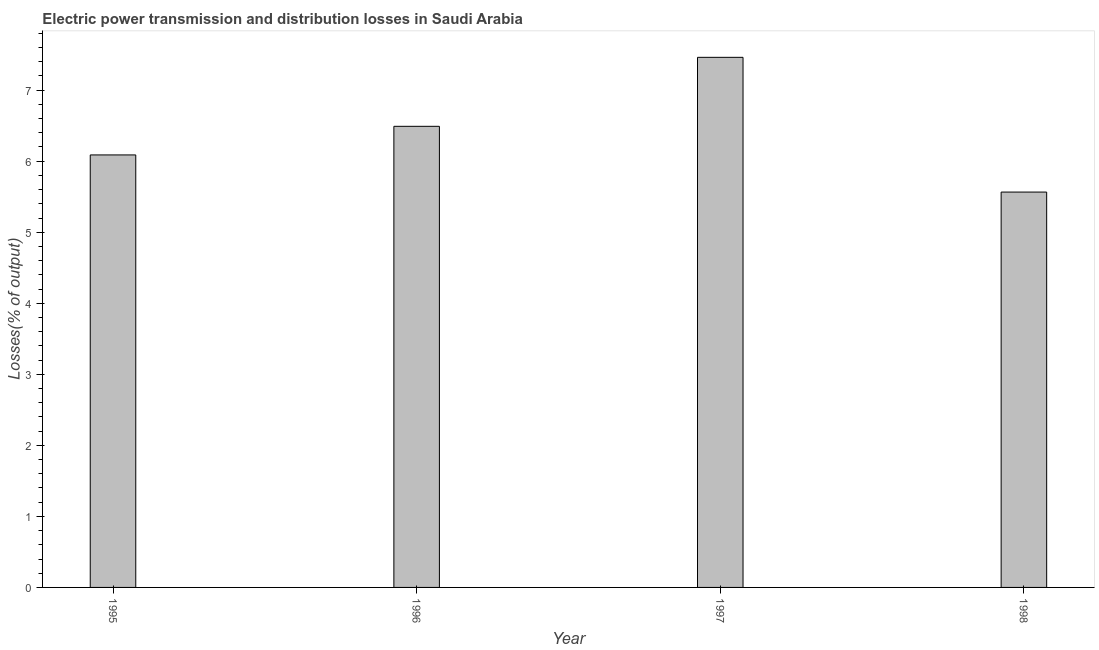Does the graph contain any zero values?
Offer a very short reply. No. Does the graph contain grids?
Keep it short and to the point. No. What is the title of the graph?
Provide a succinct answer. Electric power transmission and distribution losses in Saudi Arabia. What is the label or title of the Y-axis?
Your response must be concise. Losses(% of output). What is the electric power transmission and distribution losses in 1996?
Provide a succinct answer. 6.49. Across all years, what is the maximum electric power transmission and distribution losses?
Make the answer very short. 7.46. Across all years, what is the minimum electric power transmission and distribution losses?
Keep it short and to the point. 5.57. In which year was the electric power transmission and distribution losses maximum?
Your answer should be compact. 1997. What is the sum of the electric power transmission and distribution losses?
Keep it short and to the point. 25.61. What is the difference between the electric power transmission and distribution losses in 1995 and 1997?
Ensure brevity in your answer.  -1.37. What is the average electric power transmission and distribution losses per year?
Ensure brevity in your answer.  6.4. What is the median electric power transmission and distribution losses?
Your answer should be very brief. 6.29. What is the ratio of the electric power transmission and distribution losses in 1997 to that in 1998?
Provide a succinct answer. 1.34. Is the difference between the electric power transmission and distribution losses in 1997 and 1998 greater than the difference between any two years?
Offer a very short reply. Yes. What is the difference between the highest and the second highest electric power transmission and distribution losses?
Keep it short and to the point. 0.97. In how many years, is the electric power transmission and distribution losses greater than the average electric power transmission and distribution losses taken over all years?
Give a very brief answer. 2. How many bars are there?
Make the answer very short. 4. Are the values on the major ticks of Y-axis written in scientific E-notation?
Provide a succinct answer. No. What is the Losses(% of output) in 1995?
Make the answer very short. 6.09. What is the Losses(% of output) of 1996?
Ensure brevity in your answer.  6.49. What is the Losses(% of output) of 1997?
Give a very brief answer. 7.46. What is the Losses(% of output) of 1998?
Provide a short and direct response. 5.57. What is the difference between the Losses(% of output) in 1995 and 1996?
Your response must be concise. -0.4. What is the difference between the Losses(% of output) in 1995 and 1997?
Keep it short and to the point. -1.37. What is the difference between the Losses(% of output) in 1995 and 1998?
Provide a short and direct response. 0.52. What is the difference between the Losses(% of output) in 1996 and 1997?
Your answer should be compact. -0.97. What is the difference between the Losses(% of output) in 1996 and 1998?
Offer a terse response. 0.93. What is the difference between the Losses(% of output) in 1997 and 1998?
Keep it short and to the point. 1.9. What is the ratio of the Losses(% of output) in 1995 to that in 1996?
Offer a terse response. 0.94. What is the ratio of the Losses(% of output) in 1995 to that in 1997?
Give a very brief answer. 0.82. What is the ratio of the Losses(% of output) in 1995 to that in 1998?
Offer a very short reply. 1.09. What is the ratio of the Losses(% of output) in 1996 to that in 1997?
Give a very brief answer. 0.87. What is the ratio of the Losses(% of output) in 1996 to that in 1998?
Give a very brief answer. 1.17. What is the ratio of the Losses(% of output) in 1997 to that in 1998?
Offer a terse response. 1.34. 